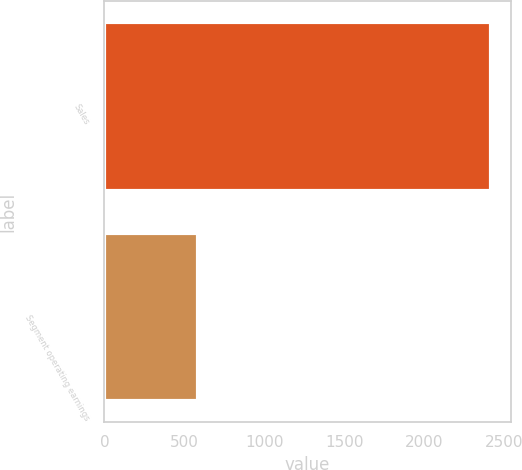Convert chart to OTSL. <chart><loc_0><loc_0><loc_500><loc_500><bar_chart><fcel>Sales<fcel>Segment operating earnings<nl><fcel>2419.7<fcel>584.7<nl></chart> 